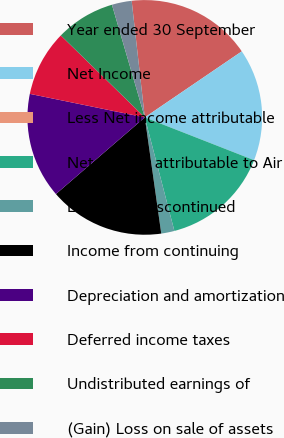<chart> <loc_0><loc_0><loc_500><loc_500><pie_chart><fcel>Year ended 30 September<fcel>Net Income<fcel>Less Net income attributable<fcel>Net income attributable to Air<fcel>Loss from discontinued<fcel>Income from continuing<fcel>Depreciation and amortization<fcel>Deferred income taxes<fcel>Undistributed earnings of<fcel>(Gain) Loss on sale of assets<nl><fcel>17.27%<fcel>15.45%<fcel>0.0%<fcel>15.0%<fcel>1.82%<fcel>15.91%<fcel>14.54%<fcel>9.09%<fcel>8.18%<fcel>2.73%<nl></chart> 